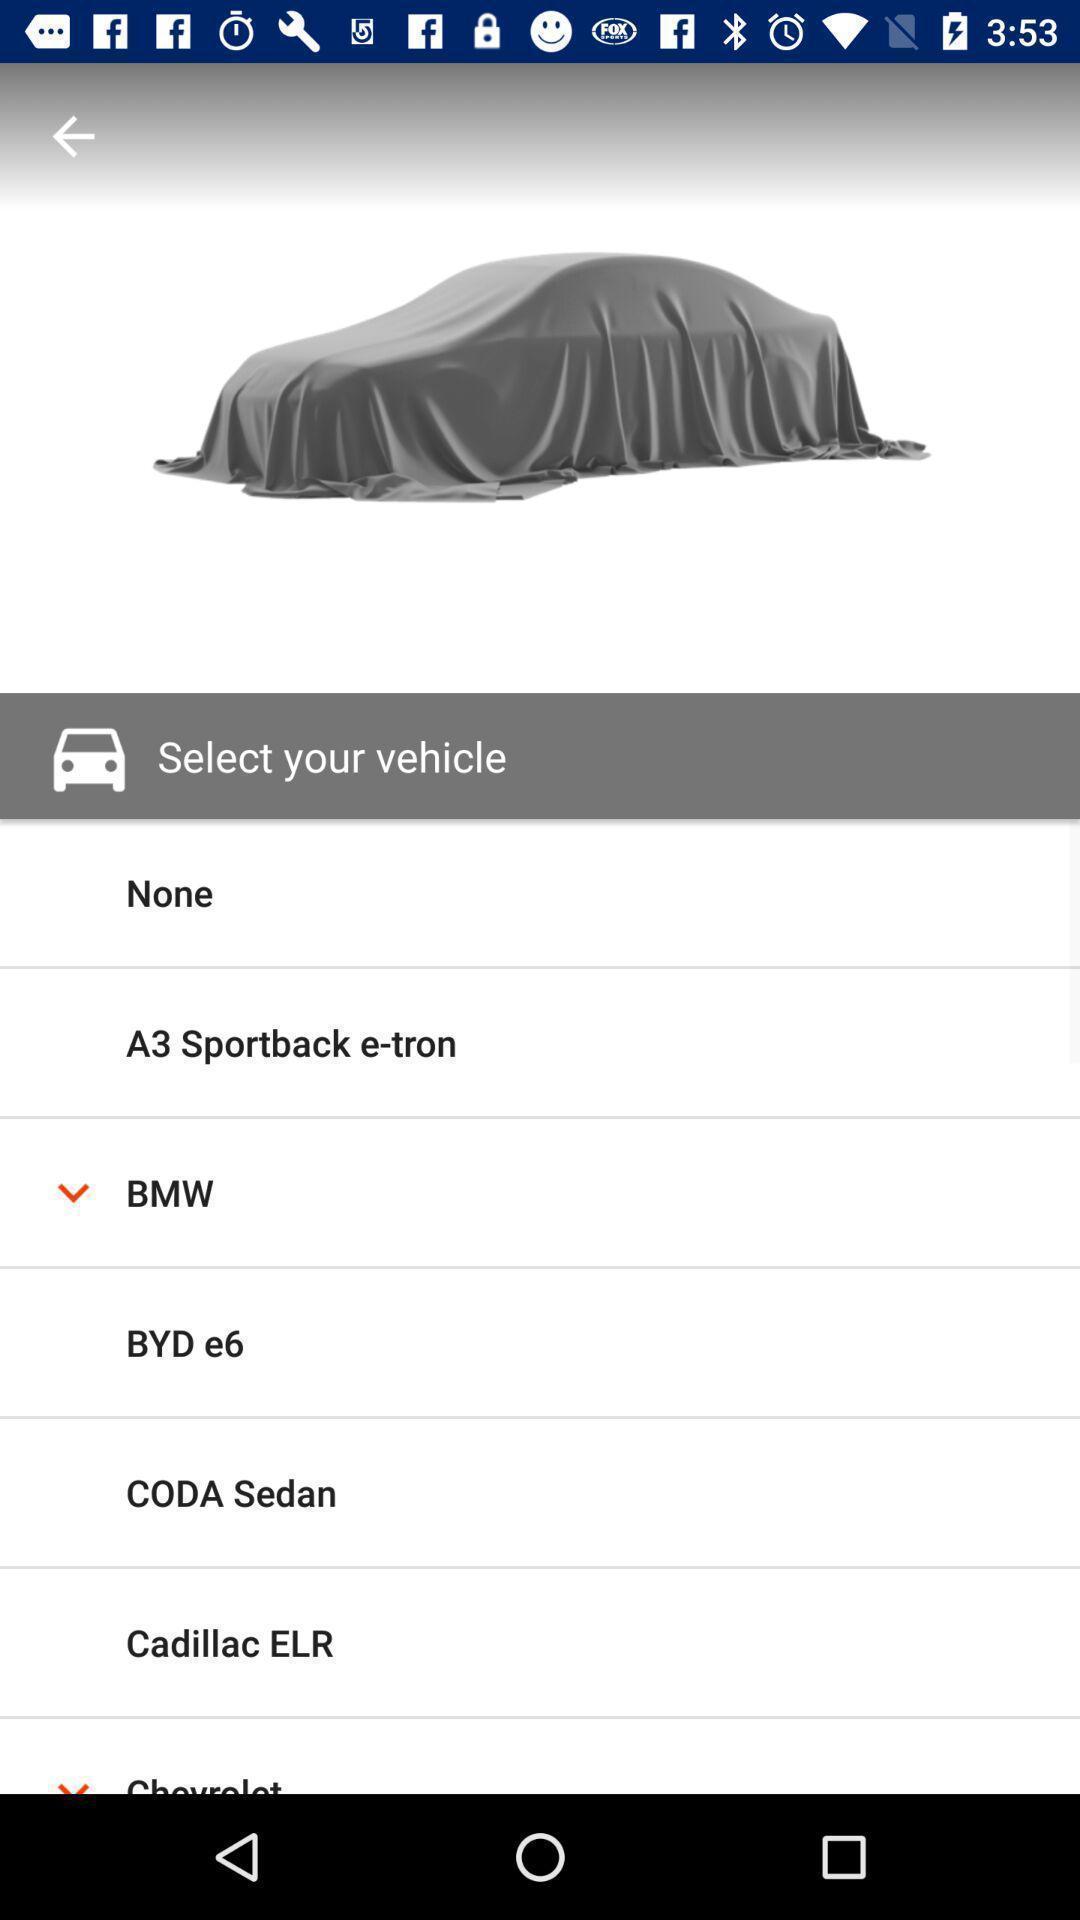What can you discern from this picture? Screen displaying list of vehicles. 